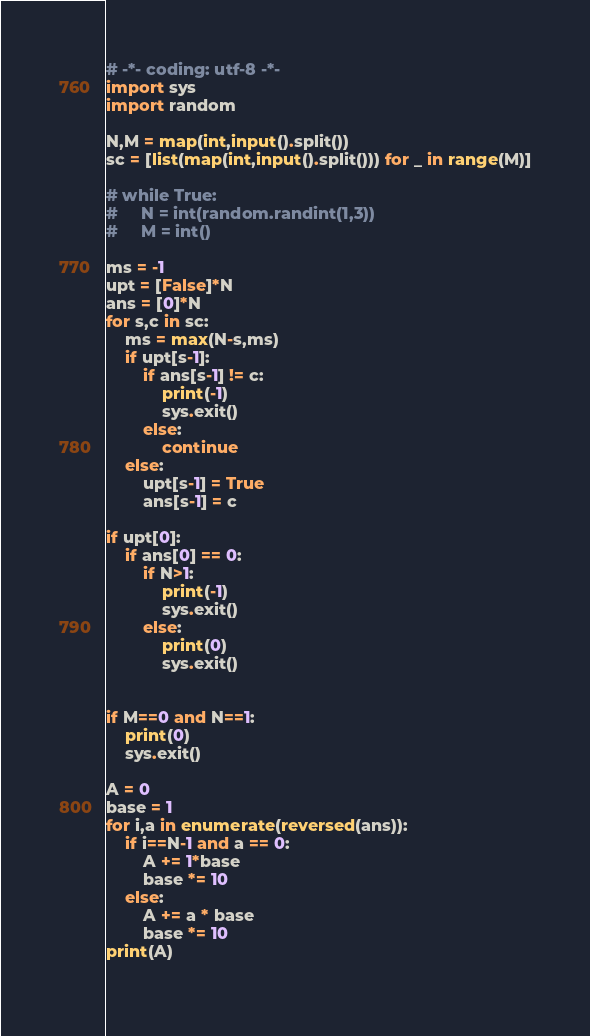Convert code to text. <code><loc_0><loc_0><loc_500><loc_500><_Python_># -*- coding: utf-8 -*-
import sys
import random

N,M = map(int,input().split())
sc = [list(map(int,input().split())) for _ in range(M)]

# while True:
#     N = int(random.randint(1,3))
#     M = int()
    
ms = -1
upt = [False]*N
ans = [0]*N
for s,c in sc:
    ms = max(N-s,ms)
    if upt[s-1]:
        if ans[s-1] != c:
            print(-1)
            sys.exit()
        else:
            continue        
    else:
        upt[s-1] = True
        ans[s-1] = c

if upt[0]:
    if ans[0] == 0:
        if N>1:
            print(-1)
            sys.exit()
        else:
            print(0)
            sys.exit()


if M==0 and N==1:
    print(0)
    sys.exit()

A = 0
base = 1
for i,a in enumerate(reversed(ans)):
    if i==N-1 and a == 0:
        A += 1*base
        base *= 10
    else:
        A += a * base
        base *= 10
print(A)
    
</code> 